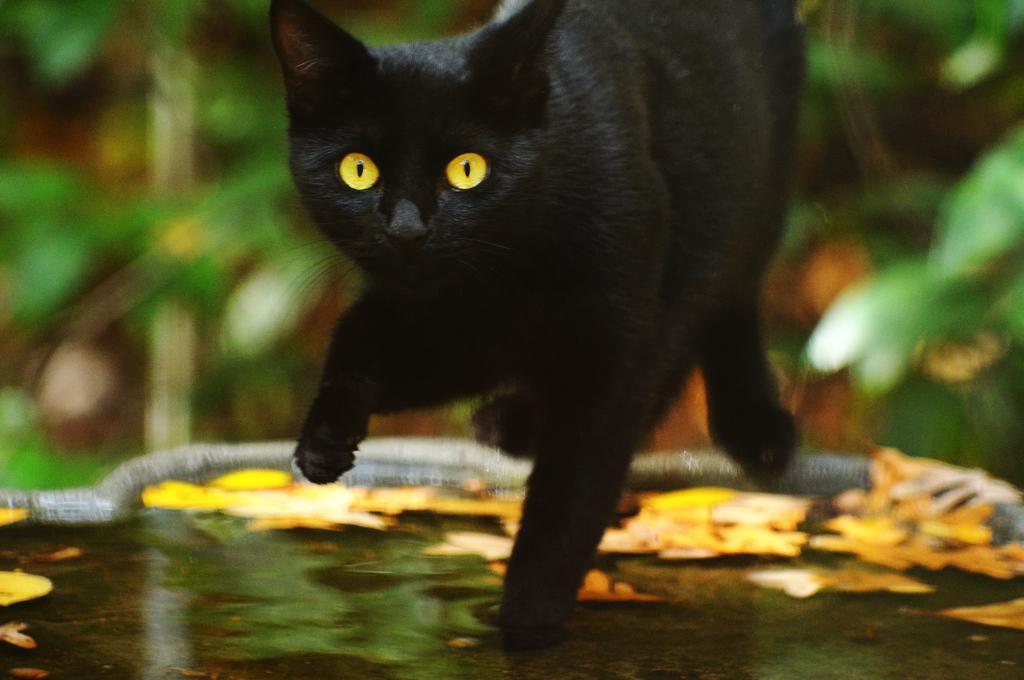Describe this image in one or two sentences. In this picture I can observe black color cat in the middle of the middle of the picture. In the bottom of the picture I can observe water. The background is completely blurred. 